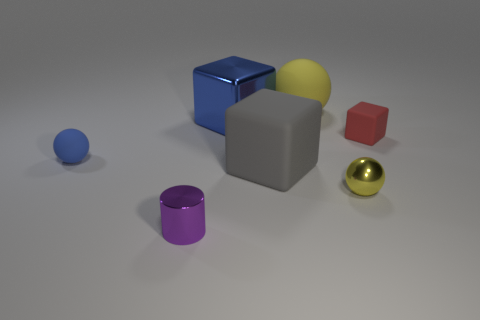Add 3 large gray rubber blocks. How many objects exist? 10 Subtract all cubes. How many objects are left? 4 Subtract 0 green spheres. How many objects are left? 7 Subtract all green metal balls. Subtract all red rubber objects. How many objects are left? 6 Add 5 big yellow rubber balls. How many big yellow rubber balls are left? 6 Add 5 tiny gray matte spheres. How many tiny gray matte spheres exist? 5 